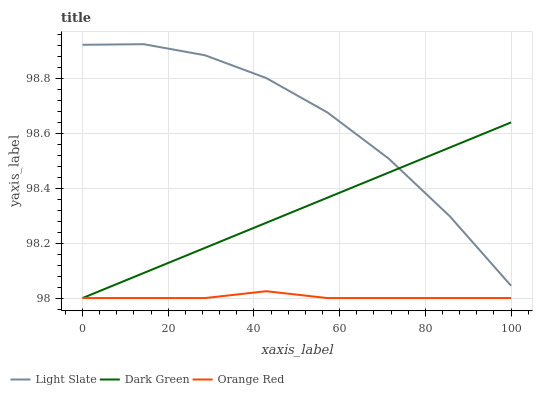Does Orange Red have the minimum area under the curve?
Answer yes or no. Yes. Does Light Slate have the maximum area under the curve?
Answer yes or no. Yes. Does Dark Green have the minimum area under the curve?
Answer yes or no. No. Does Dark Green have the maximum area under the curve?
Answer yes or no. No. Is Dark Green the smoothest?
Answer yes or no. Yes. Is Light Slate the roughest?
Answer yes or no. Yes. Is Orange Red the smoothest?
Answer yes or no. No. Is Orange Red the roughest?
Answer yes or no. No. Does Orange Red have the lowest value?
Answer yes or no. Yes. Does Light Slate have the highest value?
Answer yes or no. Yes. Does Dark Green have the highest value?
Answer yes or no. No. Is Orange Red less than Light Slate?
Answer yes or no. Yes. Is Light Slate greater than Orange Red?
Answer yes or no. Yes. Does Dark Green intersect Orange Red?
Answer yes or no. Yes. Is Dark Green less than Orange Red?
Answer yes or no. No. Is Dark Green greater than Orange Red?
Answer yes or no. No. Does Orange Red intersect Light Slate?
Answer yes or no. No. 